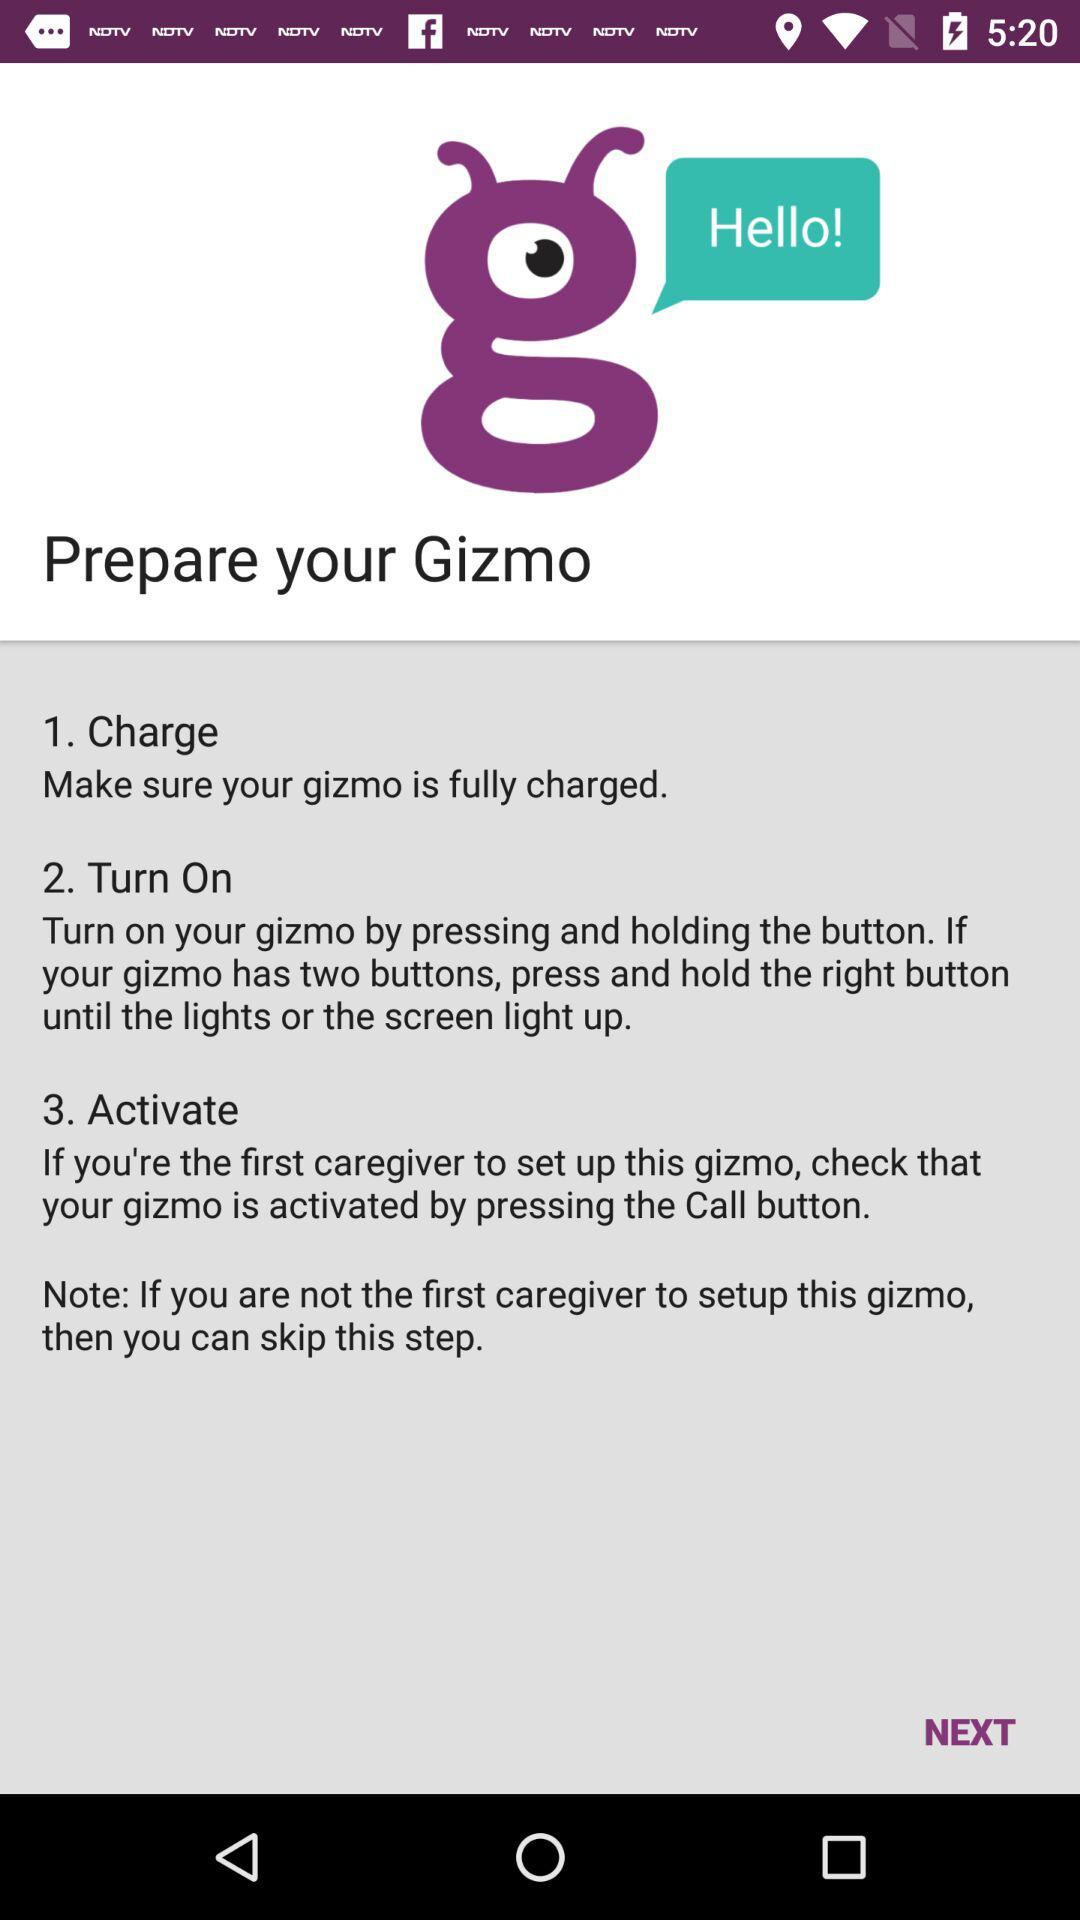How many steps are there in the process?
Answer the question using a single word or phrase. 3 